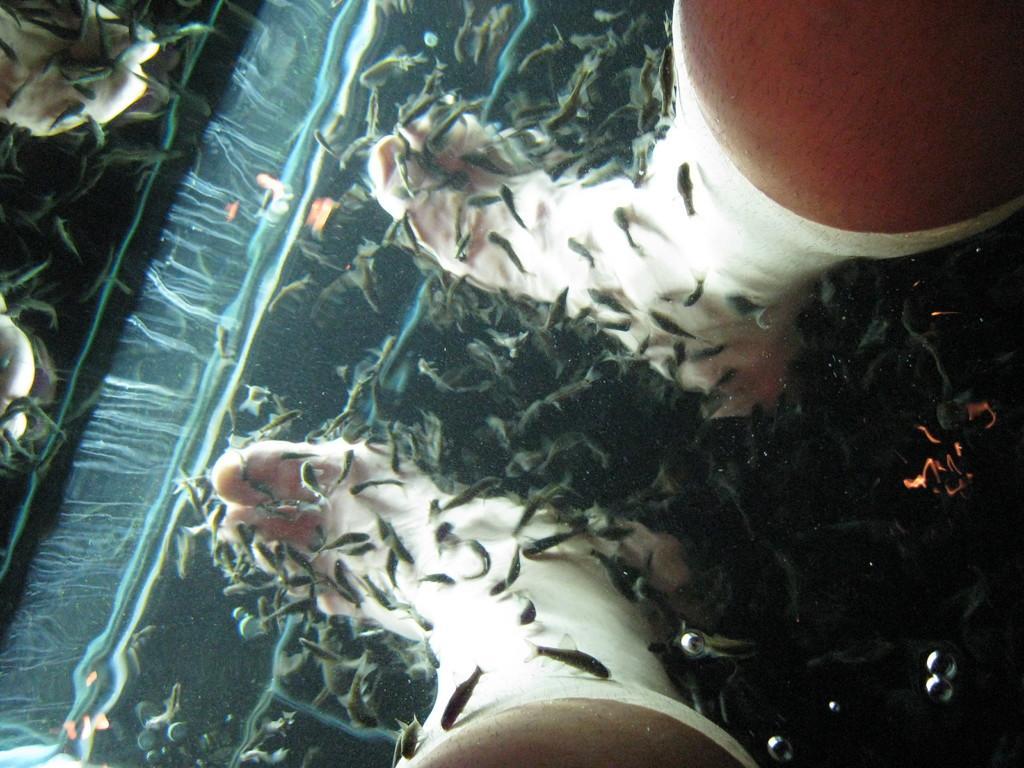Describe this image in one or two sentences. In this image I can see legs and also there is fish in the water. 